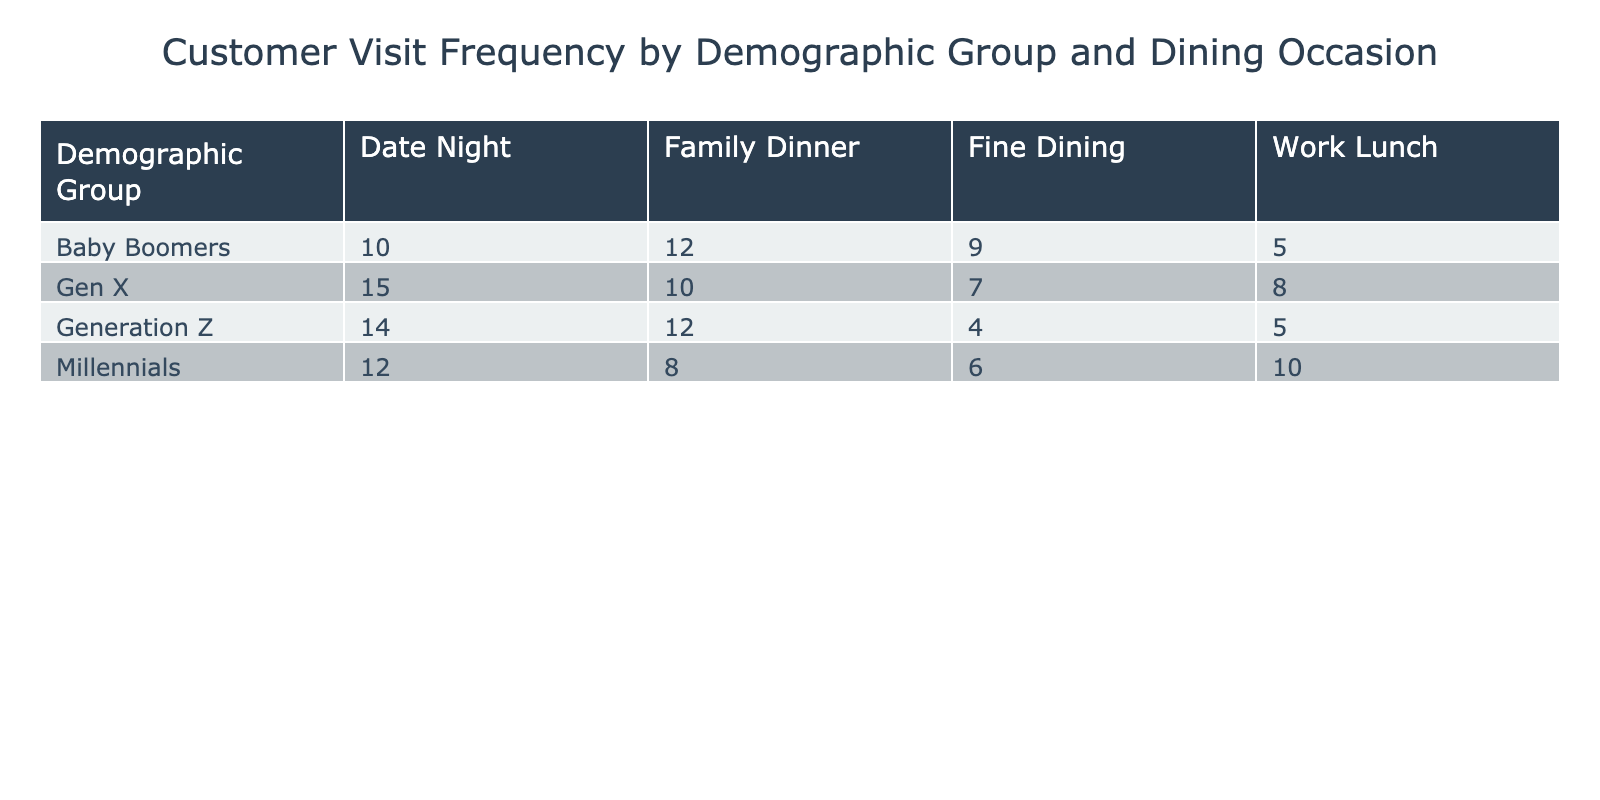What is the frequency of visits for Millennials during Date Night? Referring to the table, the frequency of visits for the demographic group Millennials during the dining occasion Date Night is clearly indicated as 12.
Answer: 12 Which demographic group has the highest frequency of visits for Fine Dining? Looking at the Fine Dining row, we see that Gen X has 7, Baby Boomers have 9, and Millennials have 6. Baby Boomers have the highest frequency of visits for Fine Dining with a value of 9.
Answer: Baby Boomers How many more visits does Gen X have compared to Baby Boomers during Family Dinner? The Family Dinner frequency for Gen X is 10, while for Baby Boomers it is 12. We have to find the difference: 10 - 12 = -2, which shows Gen X has 2 fewer visits compared to Baby Boomers.
Answer: 2 fewer What is the total frequency of visits across all demographic groups for Work Lunch? To get the total frequency of visits for Work Lunch, add together the values for all groups: Millennials (10) + Gen X (8) + Baby Boomers (5) + Generation Z (5) which sums to 28.
Answer: 28 Is it true that Generation Z visits for Fine Dining more frequently than Baby Boomers? Checking the Fine Dining frequency, Generation Z has a frequency of 4 and Baby Boomers have 9. Since 4 is less than 9, it is false that Generation Z visits more frequently for Fine Dining.
Answer: False Which demographic group has the lowest total visits across all dining occasions? We will first calculate the total visits for each group: Millennials (12 + 8 + 10 + 6 = 36), Gen X (15 + 10 + 8 + 7 = 40), Baby Boomers (10 + 12 + 5 + 9 = 36), Generation Z (14 + 12 + 5 + 4 = 35). Generation Z has the lowest total visits at 35.
Answer: Generation Z What is the average frequency of visits during Date Night across all demographic groups? The frequencies for Date Night are: Millennials (12), Gen X (15), Baby Boomers (10), and Generation Z (14). To find the average, sum these values: 12 + 15 + 10 + 14 = 51, then divide by the number of groups (4): 51 / 4 = 12.75.
Answer: 12.75 How does the total for Family Dinner compare to the total for Date Night? First calculate the totals: Family Dinner (8 + 10 + 12 + 12 = 42) and Date Night (12 + 15 + 10 + 14 = 51). Comparing these totals shows that Date Night (51) has more visits than Family Dinner (42).
Answer: Date Night has more 